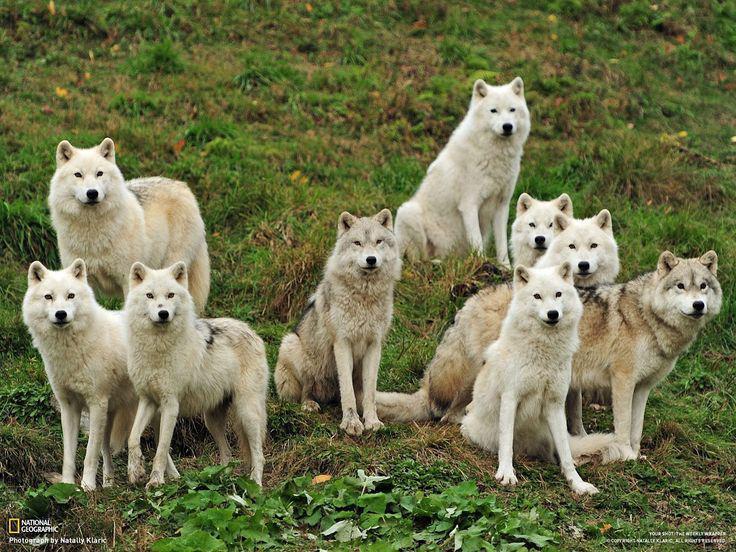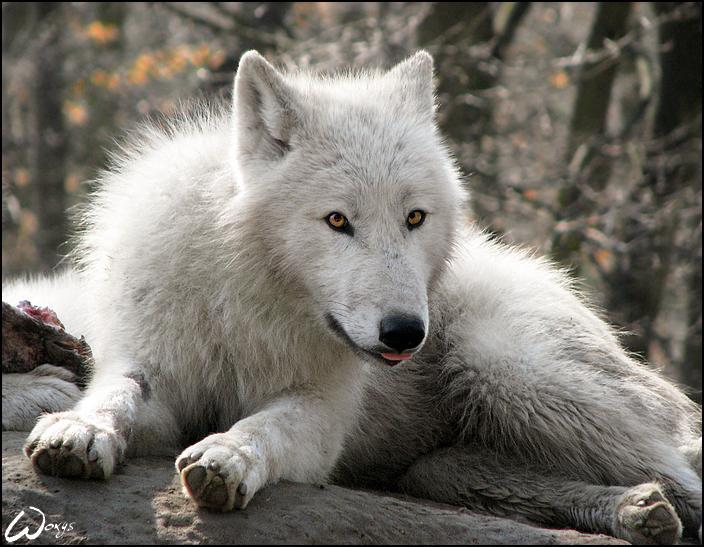The first image is the image on the left, the second image is the image on the right. Given the left and right images, does the statement "The right image features one wolf reclining with its body turned leftward and its gaze slightly rightward, and the left image contains at least three wolves." hold true? Answer yes or no. Yes. The first image is the image on the left, the second image is the image on the right. Given the left and right images, does the statement "The left image contains at least two wolves." hold true? Answer yes or no. Yes. 